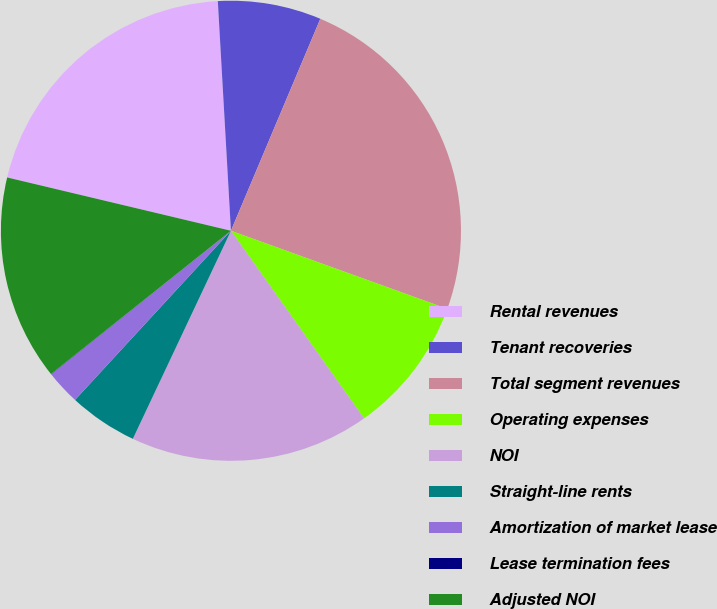Convert chart to OTSL. <chart><loc_0><loc_0><loc_500><loc_500><pie_chart><fcel>Rental revenues<fcel>Tenant recoveries<fcel>Total segment revenues<fcel>Operating expenses<fcel>NOI<fcel>Straight-line rents<fcel>Amortization of market lease<fcel>Lease termination fees<fcel>Adjusted NOI<nl><fcel>20.37%<fcel>7.26%<fcel>24.16%<fcel>9.67%<fcel>16.83%<fcel>4.84%<fcel>2.43%<fcel>0.02%<fcel>14.42%<nl></chart> 